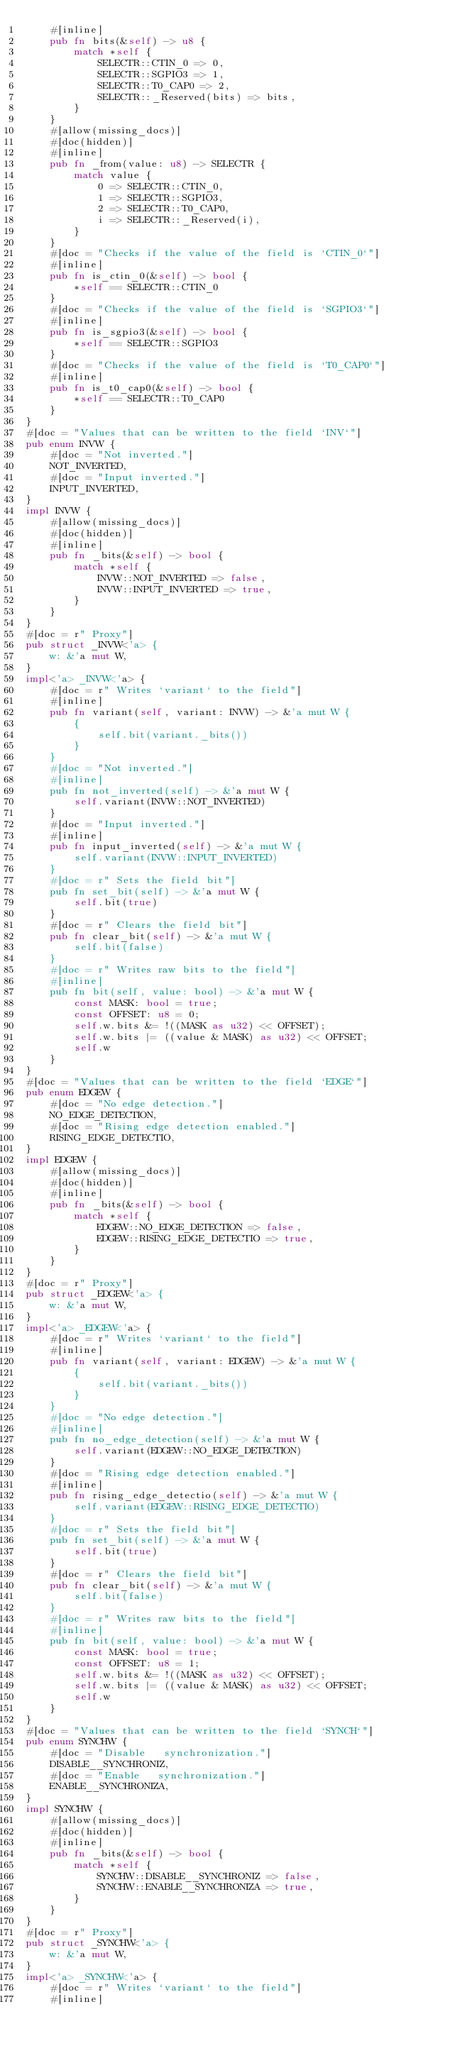Convert code to text. <code><loc_0><loc_0><loc_500><loc_500><_Rust_>    #[inline]
    pub fn bits(&self) -> u8 {
        match *self {
            SELECTR::CTIN_0 => 0,
            SELECTR::SGPIO3 => 1,
            SELECTR::T0_CAP0 => 2,
            SELECTR::_Reserved(bits) => bits,
        }
    }
    #[allow(missing_docs)]
    #[doc(hidden)]
    #[inline]
    pub fn _from(value: u8) -> SELECTR {
        match value {
            0 => SELECTR::CTIN_0,
            1 => SELECTR::SGPIO3,
            2 => SELECTR::T0_CAP0,
            i => SELECTR::_Reserved(i),
        }
    }
    #[doc = "Checks if the value of the field is `CTIN_0`"]
    #[inline]
    pub fn is_ctin_0(&self) -> bool {
        *self == SELECTR::CTIN_0
    }
    #[doc = "Checks if the value of the field is `SGPIO3`"]
    #[inline]
    pub fn is_sgpio3(&self) -> bool {
        *self == SELECTR::SGPIO3
    }
    #[doc = "Checks if the value of the field is `T0_CAP0`"]
    #[inline]
    pub fn is_t0_cap0(&self) -> bool {
        *self == SELECTR::T0_CAP0
    }
}
#[doc = "Values that can be written to the field `INV`"]
pub enum INVW {
    #[doc = "Not inverted."]
    NOT_INVERTED,
    #[doc = "Input inverted."]
    INPUT_INVERTED,
}
impl INVW {
    #[allow(missing_docs)]
    #[doc(hidden)]
    #[inline]
    pub fn _bits(&self) -> bool {
        match *self {
            INVW::NOT_INVERTED => false,
            INVW::INPUT_INVERTED => true,
        }
    }
}
#[doc = r" Proxy"]
pub struct _INVW<'a> {
    w: &'a mut W,
}
impl<'a> _INVW<'a> {
    #[doc = r" Writes `variant` to the field"]
    #[inline]
    pub fn variant(self, variant: INVW) -> &'a mut W {
        {
            self.bit(variant._bits())
        }
    }
    #[doc = "Not inverted."]
    #[inline]
    pub fn not_inverted(self) -> &'a mut W {
        self.variant(INVW::NOT_INVERTED)
    }
    #[doc = "Input inverted."]
    #[inline]
    pub fn input_inverted(self) -> &'a mut W {
        self.variant(INVW::INPUT_INVERTED)
    }
    #[doc = r" Sets the field bit"]
    pub fn set_bit(self) -> &'a mut W {
        self.bit(true)
    }
    #[doc = r" Clears the field bit"]
    pub fn clear_bit(self) -> &'a mut W {
        self.bit(false)
    }
    #[doc = r" Writes raw bits to the field"]
    #[inline]
    pub fn bit(self, value: bool) -> &'a mut W {
        const MASK: bool = true;
        const OFFSET: u8 = 0;
        self.w.bits &= !((MASK as u32) << OFFSET);
        self.w.bits |= ((value & MASK) as u32) << OFFSET;
        self.w
    }
}
#[doc = "Values that can be written to the field `EDGE`"]
pub enum EDGEW {
    #[doc = "No edge detection."]
    NO_EDGE_DETECTION,
    #[doc = "Rising edge detection enabled."]
    RISING_EDGE_DETECTIO,
}
impl EDGEW {
    #[allow(missing_docs)]
    #[doc(hidden)]
    #[inline]
    pub fn _bits(&self) -> bool {
        match *self {
            EDGEW::NO_EDGE_DETECTION => false,
            EDGEW::RISING_EDGE_DETECTIO => true,
        }
    }
}
#[doc = r" Proxy"]
pub struct _EDGEW<'a> {
    w: &'a mut W,
}
impl<'a> _EDGEW<'a> {
    #[doc = r" Writes `variant` to the field"]
    #[inline]
    pub fn variant(self, variant: EDGEW) -> &'a mut W {
        {
            self.bit(variant._bits())
        }
    }
    #[doc = "No edge detection."]
    #[inline]
    pub fn no_edge_detection(self) -> &'a mut W {
        self.variant(EDGEW::NO_EDGE_DETECTION)
    }
    #[doc = "Rising edge detection enabled."]
    #[inline]
    pub fn rising_edge_detectio(self) -> &'a mut W {
        self.variant(EDGEW::RISING_EDGE_DETECTIO)
    }
    #[doc = r" Sets the field bit"]
    pub fn set_bit(self) -> &'a mut W {
        self.bit(true)
    }
    #[doc = r" Clears the field bit"]
    pub fn clear_bit(self) -> &'a mut W {
        self.bit(false)
    }
    #[doc = r" Writes raw bits to the field"]
    #[inline]
    pub fn bit(self, value: bool) -> &'a mut W {
        const MASK: bool = true;
        const OFFSET: u8 = 1;
        self.w.bits &= !((MASK as u32) << OFFSET);
        self.w.bits |= ((value & MASK) as u32) << OFFSET;
        self.w
    }
}
#[doc = "Values that can be written to the field `SYNCH`"]
pub enum SYNCHW {
    #[doc = "Disable   synchronization."]
    DISABLE__SYNCHRONIZ,
    #[doc = "Enable   synchronization."]
    ENABLE__SYNCHRONIZA,
}
impl SYNCHW {
    #[allow(missing_docs)]
    #[doc(hidden)]
    #[inline]
    pub fn _bits(&self) -> bool {
        match *self {
            SYNCHW::DISABLE__SYNCHRONIZ => false,
            SYNCHW::ENABLE__SYNCHRONIZA => true,
        }
    }
}
#[doc = r" Proxy"]
pub struct _SYNCHW<'a> {
    w: &'a mut W,
}
impl<'a> _SYNCHW<'a> {
    #[doc = r" Writes `variant` to the field"]
    #[inline]</code> 